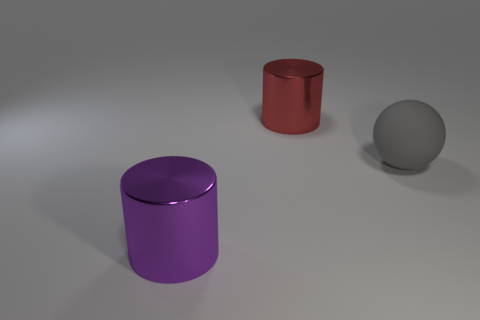What materials appear to make up the objects in the image? The objects in the image seem to have a metallic finish, with reflective surfaces suggesting they are made of metal or a material designed to mimic the appearance of metal. 